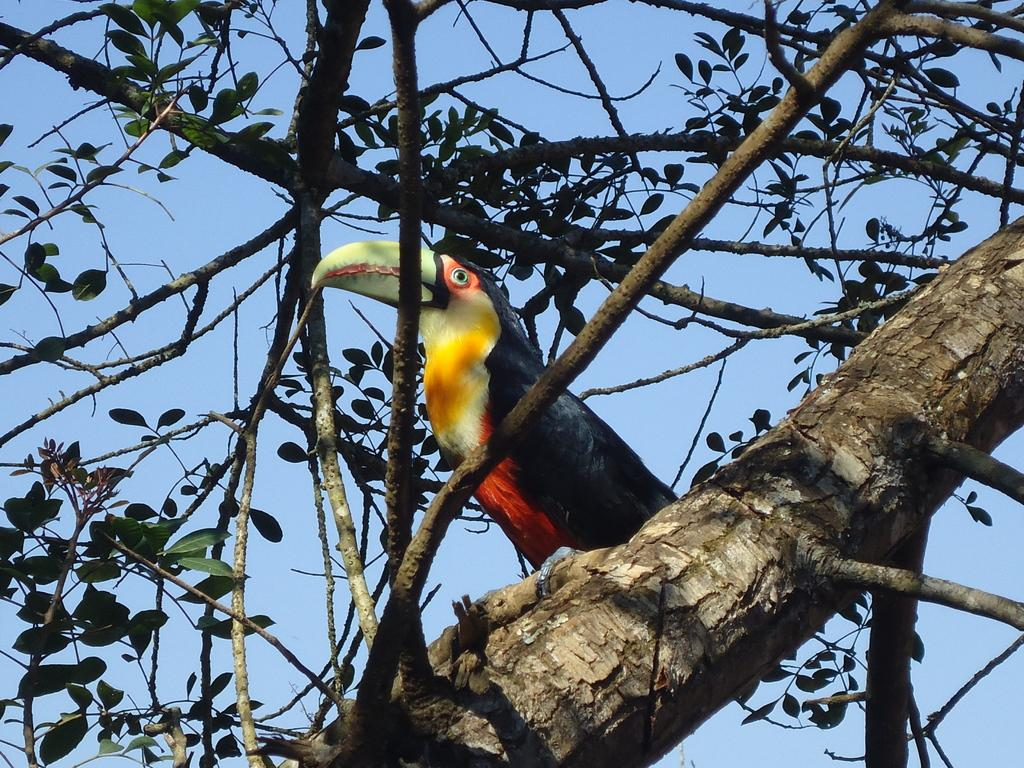What type of bird is in the image? There is a woodpecker in the image. Where is the woodpecker located? The woodpecker is on a tree. What can be seen in the background of the image? The sky is visible in the background of the image. What type of coal is the woodpecker using to make observations in the image? There is no coal present in the image, and the woodpecker is not making any observations. 